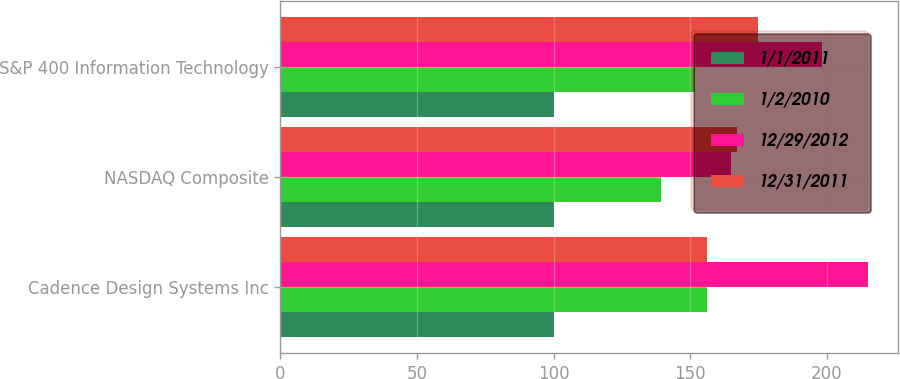Convert chart to OTSL. <chart><loc_0><loc_0><loc_500><loc_500><stacked_bar_chart><ecel><fcel>Cadence Design Systems Inc<fcel>NASDAQ Composite<fcel>S&P 400 Information Technology<nl><fcel>1/1/2011<fcel>100<fcel>100<fcel>100<nl><fcel>1/2/2010<fcel>155.99<fcel>139.32<fcel>151.58<nl><fcel>12/29/2012<fcel>215.1<fcel>164.84<fcel>198.02<nl><fcel>12/31/2011<fcel>155.99<fcel>167.06<fcel>174.88<nl></chart> 